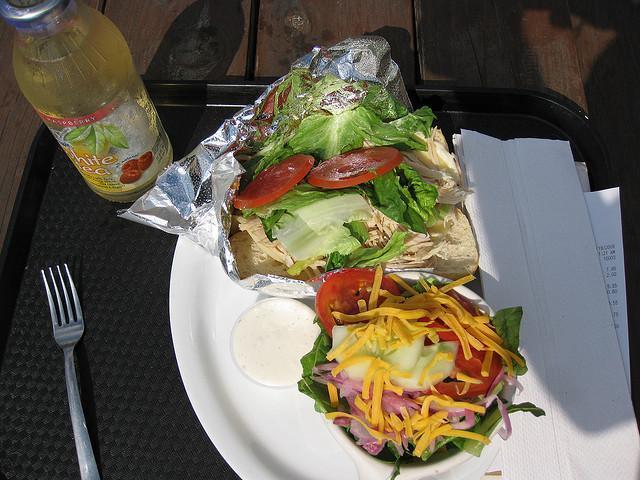How many people is this meal for?
Give a very brief answer. 1. 